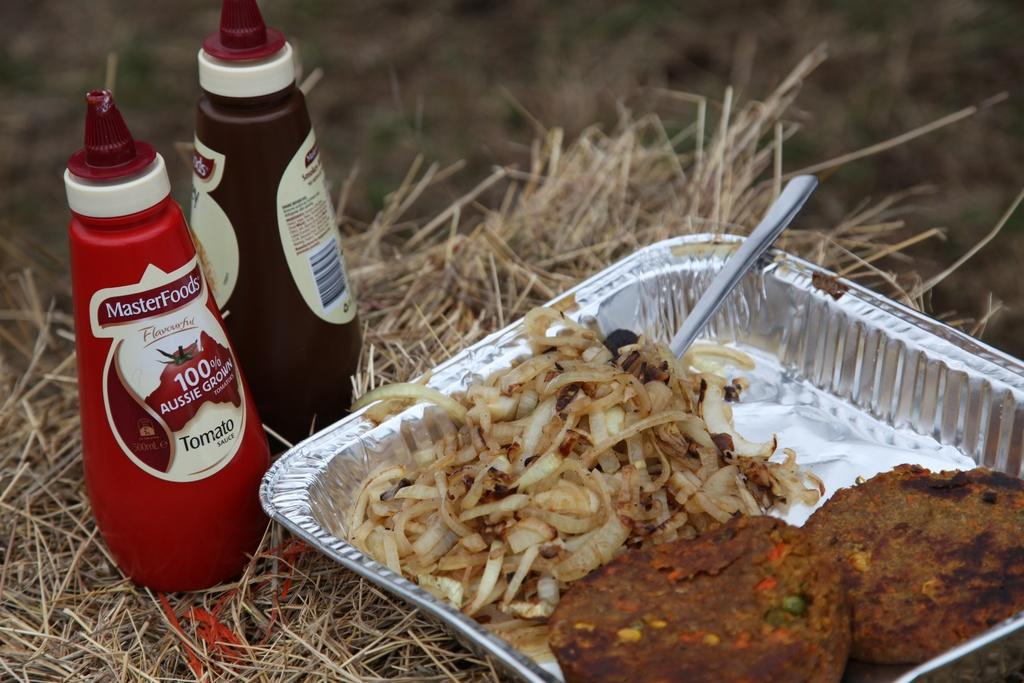Provide a one-sentence caption for the provided image. A metal serving pan full of food lies in some grass next to two MasterFoods condiment bottles. 